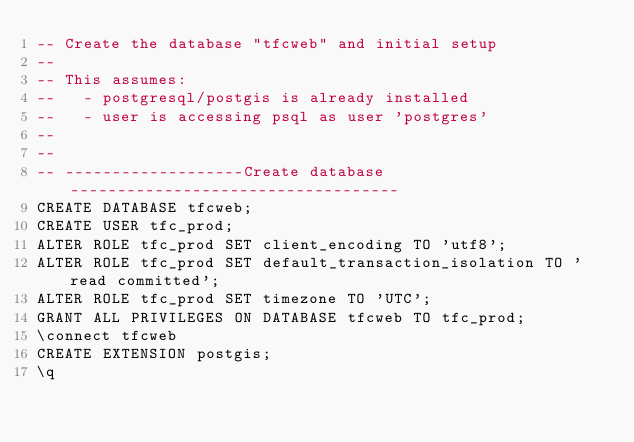Convert code to text. <code><loc_0><loc_0><loc_500><loc_500><_SQL_>-- Create the database "tfcweb" and initial setup
--
-- This assumes:
--   - postgresql/postgis is already installed
--   - user is accessing psql as user 'postgres'
--
--
-- -------------------Create database -----------------------------------
CREATE DATABASE tfcweb;
CREATE USER tfc_prod;
ALTER ROLE tfc_prod SET client_encoding TO 'utf8';
ALTER ROLE tfc_prod SET default_transaction_isolation TO 'read committed';
ALTER ROLE tfc_prod SET timezone TO 'UTC';
GRANT ALL PRIVILEGES ON DATABASE tfcweb TO tfc_prod;
\connect tfcweb
CREATE EXTENSION postgis;
\q
</code> 